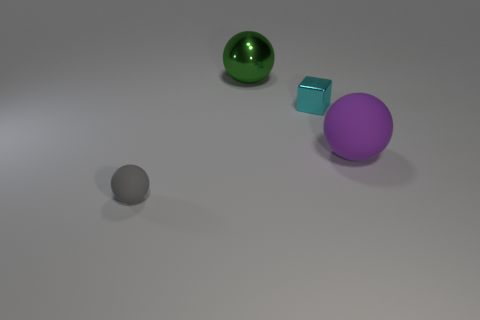Subtract all rubber spheres. How many spheres are left? 1 Subtract all purple spheres. How many spheres are left? 2 Subtract all blocks. How many objects are left? 3 Add 2 small gray matte balls. How many small gray matte balls are left? 3 Add 2 red metallic blocks. How many red metallic blocks exist? 2 Add 2 small metallic things. How many objects exist? 6 Subtract 0 brown blocks. How many objects are left? 4 Subtract 2 spheres. How many spheres are left? 1 Subtract all blue spheres. Subtract all blue blocks. How many spheres are left? 3 Subtract all red cylinders. How many purple balls are left? 1 